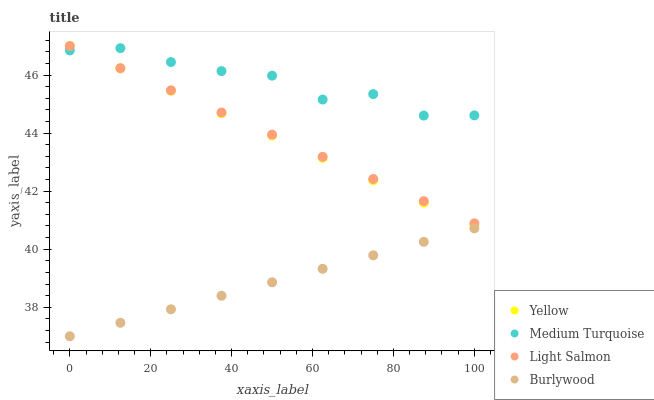Does Burlywood have the minimum area under the curve?
Answer yes or no. Yes. Does Medium Turquoise have the maximum area under the curve?
Answer yes or no. Yes. Does Light Salmon have the minimum area under the curve?
Answer yes or no. No. Does Light Salmon have the maximum area under the curve?
Answer yes or no. No. Is Yellow the smoothest?
Answer yes or no. Yes. Is Medium Turquoise the roughest?
Answer yes or no. Yes. Is Light Salmon the smoothest?
Answer yes or no. No. Is Light Salmon the roughest?
Answer yes or no. No. Does Burlywood have the lowest value?
Answer yes or no. Yes. Does Light Salmon have the lowest value?
Answer yes or no. No. Does Yellow have the highest value?
Answer yes or no. Yes. Does Medium Turquoise have the highest value?
Answer yes or no. No. Is Burlywood less than Yellow?
Answer yes or no. Yes. Is Medium Turquoise greater than Burlywood?
Answer yes or no. Yes. Does Medium Turquoise intersect Light Salmon?
Answer yes or no. Yes. Is Medium Turquoise less than Light Salmon?
Answer yes or no. No. Is Medium Turquoise greater than Light Salmon?
Answer yes or no. No. Does Burlywood intersect Yellow?
Answer yes or no. No. 